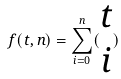Convert formula to latex. <formula><loc_0><loc_0><loc_500><loc_500>f ( t , n ) = \sum _ { i = 0 } ^ { n } ( \begin{matrix} t \\ i \end{matrix} )</formula> 